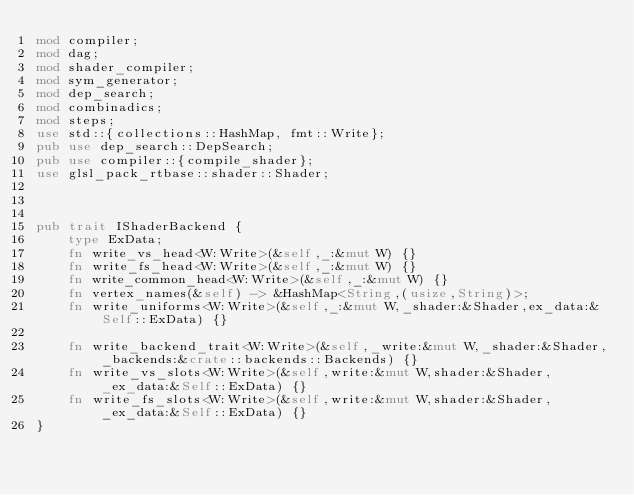Convert code to text. <code><loc_0><loc_0><loc_500><loc_500><_Rust_>mod compiler;
mod dag;
mod shader_compiler;
mod sym_generator;
mod dep_search;
mod combinadics;
mod steps;
use std::{collections::HashMap, fmt::Write};
pub use dep_search::DepSearch;
pub use compiler::{compile_shader};
use glsl_pack_rtbase::shader::Shader;



pub trait IShaderBackend {
    type ExData;
    fn write_vs_head<W:Write>(&self,_:&mut W) {}
    fn write_fs_head<W:Write>(&self,_:&mut W) {}
    fn write_common_head<W:Write>(&self,_:&mut W) {}
    fn vertex_names(&self) -> &HashMap<String,(usize,String)>;
    fn write_uniforms<W:Write>(&self,_:&mut W,_shader:&Shader,ex_data:&Self::ExData) {}

    fn write_backend_trait<W:Write>(&self,_write:&mut W,_shader:&Shader,_backends:&crate::backends::Backends) {}
    fn write_vs_slots<W:Write>(&self,write:&mut W,shader:&Shader,_ex_data:&Self::ExData) {}
    fn write_fs_slots<W:Write>(&self,write:&mut W,shader:&Shader,_ex_data:&Self::ExData) {}
}</code> 